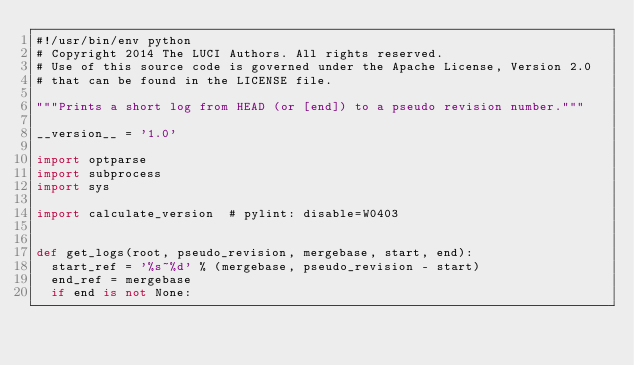Convert code to text. <code><loc_0><loc_0><loc_500><loc_500><_Python_>#!/usr/bin/env python
# Copyright 2014 The LUCI Authors. All rights reserved.
# Use of this source code is governed under the Apache License, Version 2.0
# that can be found in the LICENSE file.

"""Prints a short log from HEAD (or [end]) to a pseudo revision number."""

__version__ = '1.0'

import optparse
import subprocess
import sys

import calculate_version  # pylint: disable=W0403


def get_logs(root, pseudo_revision, mergebase, start, end):
  start_ref = '%s~%d' % (mergebase, pseudo_revision - start)
  end_ref = mergebase
  if end is not None:</code> 